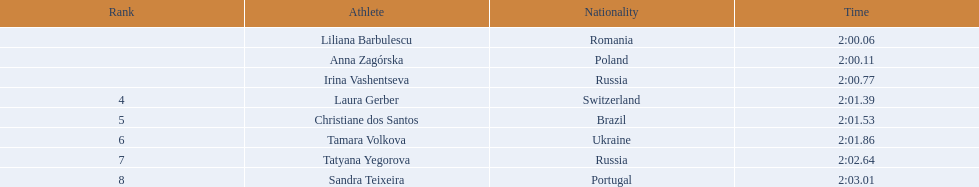Can you list all the athletes involved? Liliana Barbulescu, Anna Zagórska, Irina Vashentseva, Laura Gerber, Christiane dos Santos, Tamara Volkova, Tatyana Yegorova, Sandra Teixeira. What were the times they took to finish? 2:00.06, 2:00.11, 2:00.77, 2:01.39, 2:01.53, 2:01.86, 2:02.64, 2:03.01. Who was the athlete that finished the fastest? Liliana Barbulescu. 